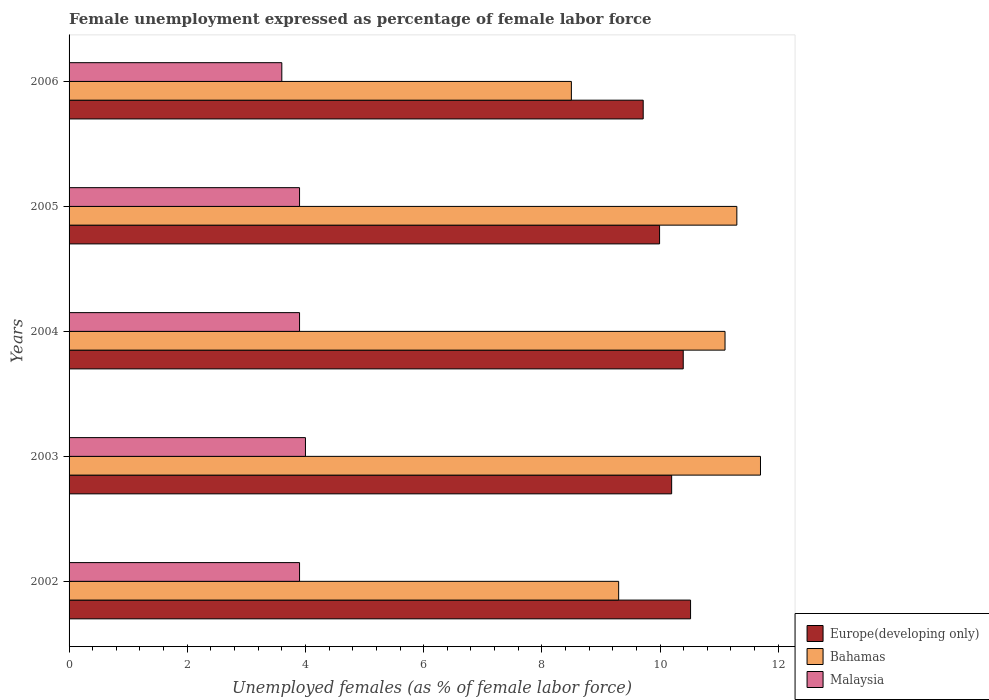How many bars are there on the 5th tick from the top?
Offer a very short reply. 3. How many bars are there on the 1st tick from the bottom?
Offer a very short reply. 3. What is the label of the 3rd group of bars from the top?
Give a very brief answer. 2004. What is the unemployment in females in in Bahamas in 2005?
Your response must be concise. 11.3. Across all years, what is the maximum unemployment in females in in Europe(developing only)?
Your answer should be compact. 10.52. Across all years, what is the minimum unemployment in females in in Malaysia?
Make the answer very short. 3.6. In which year was the unemployment in females in in Bahamas maximum?
Give a very brief answer. 2003. What is the total unemployment in females in in Europe(developing only) in the graph?
Your response must be concise. 50.81. What is the difference between the unemployment in females in in Bahamas in 2002 and that in 2006?
Make the answer very short. 0.8. What is the difference between the unemployment in females in in Europe(developing only) in 2006 and the unemployment in females in in Bahamas in 2005?
Your answer should be very brief. -1.58. What is the average unemployment in females in in Bahamas per year?
Give a very brief answer. 10.38. In the year 2004, what is the difference between the unemployment in females in in Europe(developing only) and unemployment in females in in Bahamas?
Keep it short and to the point. -0.71. What is the ratio of the unemployment in females in in Bahamas in 2004 to that in 2006?
Provide a succinct answer. 1.31. What is the difference between the highest and the second highest unemployment in females in in Malaysia?
Provide a short and direct response. 0.1. What is the difference between the highest and the lowest unemployment in females in in Malaysia?
Your response must be concise. 0.4. In how many years, is the unemployment in females in in Bahamas greater than the average unemployment in females in in Bahamas taken over all years?
Provide a succinct answer. 3. What does the 1st bar from the top in 2002 represents?
Ensure brevity in your answer.  Malaysia. What does the 2nd bar from the bottom in 2006 represents?
Make the answer very short. Bahamas. Is it the case that in every year, the sum of the unemployment in females in in Europe(developing only) and unemployment in females in in Bahamas is greater than the unemployment in females in in Malaysia?
Your response must be concise. Yes. How many bars are there?
Ensure brevity in your answer.  15. How many years are there in the graph?
Ensure brevity in your answer.  5. Does the graph contain any zero values?
Offer a very short reply. No. Does the graph contain grids?
Offer a very short reply. No. What is the title of the graph?
Your response must be concise. Female unemployment expressed as percentage of female labor force. Does "Tunisia" appear as one of the legend labels in the graph?
Provide a short and direct response. No. What is the label or title of the X-axis?
Your answer should be compact. Unemployed females (as % of female labor force). What is the Unemployed females (as % of female labor force) in Europe(developing only) in 2002?
Provide a succinct answer. 10.52. What is the Unemployed females (as % of female labor force) of Bahamas in 2002?
Your answer should be compact. 9.3. What is the Unemployed females (as % of female labor force) in Malaysia in 2002?
Your answer should be very brief. 3.9. What is the Unemployed females (as % of female labor force) of Europe(developing only) in 2003?
Make the answer very short. 10.2. What is the Unemployed females (as % of female labor force) of Bahamas in 2003?
Your answer should be compact. 11.7. What is the Unemployed females (as % of female labor force) of Malaysia in 2003?
Offer a very short reply. 4. What is the Unemployed females (as % of female labor force) in Europe(developing only) in 2004?
Ensure brevity in your answer.  10.39. What is the Unemployed females (as % of female labor force) of Bahamas in 2004?
Ensure brevity in your answer.  11.1. What is the Unemployed females (as % of female labor force) of Malaysia in 2004?
Make the answer very short. 3.9. What is the Unemployed females (as % of female labor force) in Europe(developing only) in 2005?
Give a very brief answer. 9.99. What is the Unemployed females (as % of female labor force) of Bahamas in 2005?
Ensure brevity in your answer.  11.3. What is the Unemployed females (as % of female labor force) in Malaysia in 2005?
Your response must be concise. 3.9. What is the Unemployed females (as % of female labor force) of Europe(developing only) in 2006?
Your answer should be compact. 9.72. What is the Unemployed females (as % of female labor force) of Bahamas in 2006?
Keep it short and to the point. 8.5. What is the Unemployed females (as % of female labor force) in Malaysia in 2006?
Provide a short and direct response. 3.6. Across all years, what is the maximum Unemployed females (as % of female labor force) in Europe(developing only)?
Make the answer very short. 10.52. Across all years, what is the maximum Unemployed females (as % of female labor force) of Bahamas?
Make the answer very short. 11.7. Across all years, what is the minimum Unemployed females (as % of female labor force) in Europe(developing only)?
Keep it short and to the point. 9.72. Across all years, what is the minimum Unemployed females (as % of female labor force) in Bahamas?
Offer a terse response. 8.5. Across all years, what is the minimum Unemployed females (as % of female labor force) of Malaysia?
Ensure brevity in your answer.  3.6. What is the total Unemployed females (as % of female labor force) in Europe(developing only) in the graph?
Your response must be concise. 50.81. What is the total Unemployed females (as % of female labor force) of Bahamas in the graph?
Offer a terse response. 51.9. What is the total Unemployed females (as % of female labor force) of Malaysia in the graph?
Provide a succinct answer. 19.3. What is the difference between the Unemployed females (as % of female labor force) of Europe(developing only) in 2002 and that in 2003?
Keep it short and to the point. 0.32. What is the difference between the Unemployed females (as % of female labor force) of Malaysia in 2002 and that in 2003?
Your answer should be very brief. -0.1. What is the difference between the Unemployed females (as % of female labor force) in Europe(developing only) in 2002 and that in 2004?
Your answer should be very brief. 0.12. What is the difference between the Unemployed females (as % of female labor force) of Europe(developing only) in 2002 and that in 2005?
Your response must be concise. 0.52. What is the difference between the Unemployed females (as % of female labor force) of Bahamas in 2002 and that in 2005?
Keep it short and to the point. -2. What is the difference between the Unemployed females (as % of female labor force) of Europe(developing only) in 2002 and that in 2006?
Give a very brief answer. 0.8. What is the difference between the Unemployed females (as % of female labor force) in Bahamas in 2002 and that in 2006?
Give a very brief answer. 0.8. What is the difference between the Unemployed females (as % of female labor force) in Malaysia in 2002 and that in 2006?
Your answer should be compact. 0.3. What is the difference between the Unemployed females (as % of female labor force) of Europe(developing only) in 2003 and that in 2004?
Your response must be concise. -0.2. What is the difference between the Unemployed females (as % of female labor force) of Malaysia in 2003 and that in 2004?
Make the answer very short. 0.1. What is the difference between the Unemployed females (as % of female labor force) in Europe(developing only) in 2003 and that in 2005?
Your response must be concise. 0.2. What is the difference between the Unemployed females (as % of female labor force) of Europe(developing only) in 2003 and that in 2006?
Your answer should be compact. 0.48. What is the difference between the Unemployed females (as % of female labor force) of Bahamas in 2003 and that in 2006?
Give a very brief answer. 3.2. What is the difference between the Unemployed females (as % of female labor force) of Europe(developing only) in 2004 and that in 2005?
Provide a short and direct response. 0.4. What is the difference between the Unemployed females (as % of female labor force) in Bahamas in 2004 and that in 2005?
Your response must be concise. -0.2. What is the difference between the Unemployed females (as % of female labor force) of Europe(developing only) in 2004 and that in 2006?
Offer a very short reply. 0.68. What is the difference between the Unemployed females (as % of female labor force) in Europe(developing only) in 2005 and that in 2006?
Your answer should be compact. 0.28. What is the difference between the Unemployed females (as % of female labor force) in Bahamas in 2005 and that in 2006?
Your answer should be very brief. 2.8. What is the difference between the Unemployed females (as % of female labor force) in Europe(developing only) in 2002 and the Unemployed females (as % of female labor force) in Bahamas in 2003?
Give a very brief answer. -1.18. What is the difference between the Unemployed females (as % of female labor force) of Europe(developing only) in 2002 and the Unemployed females (as % of female labor force) of Malaysia in 2003?
Provide a short and direct response. 6.52. What is the difference between the Unemployed females (as % of female labor force) in Europe(developing only) in 2002 and the Unemployed females (as % of female labor force) in Bahamas in 2004?
Provide a succinct answer. -0.58. What is the difference between the Unemployed females (as % of female labor force) of Europe(developing only) in 2002 and the Unemployed females (as % of female labor force) of Malaysia in 2004?
Ensure brevity in your answer.  6.62. What is the difference between the Unemployed females (as % of female labor force) in Europe(developing only) in 2002 and the Unemployed females (as % of female labor force) in Bahamas in 2005?
Your answer should be compact. -0.78. What is the difference between the Unemployed females (as % of female labor force) in Europe(developing only) in 2002 and the Unemployed females (as % of female labor force) in Malaysia in 2005?
Your answer should be compact. 6.62. What is the difference between the Unemployed females (as % of female labor force) of Europe(developing only) in 2002 and the Unemployed females (as % of female labor force) of Bahamas in 2006?
Make the answer very short. 2.02. What is the difference between the Unemployed females (as % of female labor force) of Europe(developing only) in 2002 and the Unemployed females (as % of female labor force) of Malaysia in 2006?
Ensure brevity in your answer.  6.92. What is the difference between the Unemployed females (as % of female labor force) of Europe(developing only) in 2003 and the Unemployed females (as % of female labor force) of Bahamas in 2004?
Make the answer very short. -0.9. What is the difference between the Unemployed females (as % of female labor force) in Europe(developing only) in 2003 and the Unemployed females (as % of female labor force) in Malaysia in 2004?
Keep it short and to the point. 6.3. What is the difference between the Unemployed females (as % of female labor force) of Bahamas in 2003 and the Unemployed females (as % of female labor force) of Malaysia in 2004?
Your response must be concise. 7.8. What is the difference between the Unemployed females (as % of female labor force) of Europe(developing only) in 2003 and the Unemployed females (as % of female labor force) of Bahamas in 2005?
Make the answer very short. -1.1. What is the difference between the Unemployed females (as % of female labor force) of Europe(developing only) in 2003 and the Unemployed females (as % of female labor force) of Malaysia in 2005?
Keep it short and to the point. 6.3. What is the difference between the Unemployed females (as % of female labor force) in Bahamas in 2003 and the Unemployed females (as % of female labor force) in Malaysia in 2005?
Your answer should be very brief. 7.8. What is the difference between the Unemployed females (as % of female labor force) in Europe(developing only) in 2003 and the Unemployed females (as % of female labor force) in Bahamas in 2006?
Provide a succinct answer. 1.7. What is the difference between the Unemployed females (as % of female labor force) in Europe(developing only) in 2003 and the Unemployed females (as % of female labor force) in Malaysia in 2006?
Provide a short and direct response. 6.6. What is the difference between the Unemployed females (as % of female labor force) of Bahamas in 2003 and the Unemployed females (as % of female labor force) of Malaysia in 2006?
Ensure brevity in your answer.  8.1. What is the difference between the Unemployed females (as % of female labor force) of Europe(developing only) in 2004 and the Unemployed females (as % of female labor force) of Bahamas in 2005?
Provide a short and direct response. -0.91. What is the difference between the Unemployed females (as % of female labor force) of Europe(developing only) in 2004 and the Unemployed females (as % of female labor force) of Malaysia in 2005?
Give a very brief answer. 6.49. What is the difference between the Unemployed females (as % of female labor force) of Europe(developing only) in 2004 and the Unemployed females (as % of female labor force) of Bahamas in 2006?
Offer a very short reply. 1.89. What is the difference between the Unemployed females (as % of female labor force) of Europe(developing only) in 2004 and the Unemployed females (as % of female labor force) of Malaysia in 2006?
Provide a succinct answer. 6.79. What is the difference between the Unemployed females (as % of female labor force) of Bahamas in 2004 and the Unemployed females (as % of female labor force) of Malaysia in 2006?
Provide a succinct answer. 7.5. What is the difference between the Unemployed females (as % of female labor force) of Europe(developing only) in 2005 and the Unemployed females (as % of female labor force) of Bahamas in 2006?
Make the answer very short. 1.49. What is the difference between the Unemployed females (as % of female labor force) in Europe(developing only) in 2005 and the Unemployed females (as % of female labor force) in Malaysia in 2006?
Offer a terse response. 6.39. What is the difference between the Unemployed females (as % of female labor force) of Bahamas in 2005 and the Unemployed females (as % of female labor force) of Malaysia in 2006?
Offer a very short reply. 7.7. What is the average Unemployed females (as % of female labor force) of Europe(developing only) per year?
Offer a terse response. 10.16. What is the average Unemployed females (as % of female labor force) of Bahamas per year?
Give a very brief answer. 10.38. What is the average Unemployed females (as % of female labor force) in Malaysia per year?
Offer a very short reply. 3.86. In the year 2002, what is the difference between the Unemployed females (as % of female labor force) of Europe(developing only) and Unemployed females (as % of female labor force) of Bahamas?
Keep it short and to the point. 1.22. In the year 2002, what is the difference between the Unemployed females (as % of female labor force) in Europe(developing only) and Unemployed females (as % of female labor force) in Malaysia?
Provide a succinct answer. 6.62. In the year 2002, what is the difference between the Unemployed females (as % of female labor force) in Bahamas and Unemployed females (as % of female labor force) in Malaysia?
Provide a short and direct response. 5.4. In the year 2003, what is the difference between the Unemployed females (as % of female labor force) in Europe(developing only) and Unemployed females (as % of female labor force) in Bahamas?
Your answer should be compact. -1.5. In the year 2003, what is the difference between the Unemployed females (as % of female labor force) of Europe(developing only) and Unemployed females (as % of female labor force) of Malaysia?
Keep it short and to the point. 6.2. In the year 2004, what is the difference between the Unemployed females (as % of female labor force) of Europe(developing only) and Unemployed females (as % of female labor force) of Bahamas?
Make the answer very short. -0.71. In the year 2004, what is the difference between the Unemployed females (as % of female labor force) in Europe(developing only) and Unemployed females (as % of female labor force) in Malaysia?
Make the answer very short. 6.49. In the year 2005, what is the difference between the Unemployed females (as % of female labor force) in Europe(developing only) and Unemployed females (as % of female labor force) in Bahamas?
Give a very brief answer. -1.31. In the year 2005, what is the difference between the Unemployed females (as % of female labor force) in Europe(developing only) and Unemployed females (as % of female labor force) in Malaysia?
Your answer should be compact. 6.09. In the year 2005, what is the difference between the Unemployed females (as % of female labor force) in Bahamas and Unemployed females (as % of female labor force) in Malaysia?
Offer a terse response. 7.4. In the year 2006, what is the difference between the Unemployed females (as % of female labor force) in Europe(developing only) and Unemployed females (as % of female labor force) in Bahamas?
Provide a succinct answer. 1.22. In the year 2006, what is the difference between the Unemployed females (as % of female labor force) of Europe(developing only) and Unemployed females (as % of female labor force) of Malaysia?
Provide a succinct answer. 6.12. What is the ratio of the Unemployed females (as % of female labor force) of Europe(developing only) in 2002 to that in 2003?
Provide a succinct answer. 1.03. What is the ratio of the Unemployed females (as % of female labor force) in Bahamas in 2002 to that in 2003?
Give a very brief answer. 0.79. What is the ratio of the Unemployed females (as % of female labor force) of Europe(developing only) in 2002 to that in 2004?
Offer a terse response. 1.01. What is the ratio of the Unemployed females (as % of female labor force) of Bahamas in 2002 to that in 2004?
Ensure brevity in your answer.  0.84. What is the ratio of the Unemployed females (as % of female labor force) of Europe(developing only) in 2002 to that in 2005?
Offer a terse response. 1.05. What is the ratio of the Unemployed females (as % of female labor force) in Bahamas in 2002 to that in 2005?
Offer a terse response. 0.82. What is the ratio of the Unemployed females (as % of female labor force) in Europe(developing only) in 2002 to that in 2006?
Offer a very short reply. 1.08. What is the ratio of the Unemployed females (as % of female labor force) of Bahamas in 2002 to that in 2006?
Provide a succinct answer. 1.09. What is the ratio of the Unemployed females (as % of female labor force) in Malaysia in 2002 to that in 2006?
Provide a short and direct response. 1.08. What is the ratio of the Unemployed females (as % of female labor force) of Europe(developing only) in 2003 to that in 2004?
Make the answer very short. 0.98. What is the ratio of the Unemployed females (as % of female labor force) in Bahamas in 2003 to that in 2004?
Provide a succinct answer. 1.05. What is the ratio of the Unemployed females (as % of female labor force) in Malaysia in 2003 to that in 2004?
Your answer should be very brief. 1.03. What is the ratio of the Unemployed females (as % of female labor force) in Europe(developing only) in 2003 to that in 2005?
Your answer should be compact. 1.02. What is the ratio of the Unemployed females (as % of female labor force) in Bahamas in 2003 to that in 2005?
Provide a short and direct response. 1.04. What is the ratio of the Unemployed females (as % of female labor force) in Malaysia in 2003 to that in 2005?
Ensure brevity in your answer.  1.03. What is the ratio of the Unemployed females (as % of female labor force) of Europe(developing only) in 2003 to that in 2006?
Give a very brief answer. 1.05. What is the ratio of the Unemployed females (as % of female labor force) in Bahamas in 2003 to that in 2006?
Your answer should be very brief. 1.38. What is the ratio of the Unemployed females (as % of female labor force) in Europe(developing only) in 2004 to that in 2005?
Make the answer very short. 1.04. What is the ratio of the Unemployed females (as % of female labor force) in Bahamas in 2004 to that in 2005?
Ensure brevity in your answer.  0.98. What is the ratio of the Unemployed females (as % of female labor force) of Malaysia in 2004 to that in 2005?
Provide a short and direct response. 1. What is the ratio of the Unemployed females (as % of female labor force) of Europe(developing only) in 2004 to that in 2006?
Provide a short and direct response. 1.07. What is the ratio of the Unemployed females (as % of female labor force) in Bahamas in 2004 to that in 2006?
Keep it short and to the point. 1.31. What is the ratio of the Unemployed females (as % of female labor force) in Europe(developing only) in 2005 to that in 2006?
Give a very brief answer. 1.03. What is the ratio of the Unemployed females (as % of female labor force) in Bahamas in 2005 to that in 2006?
Give a very brief answer. 1.33. What is the difference between the highest and the second highest Unemployed females (as % of female labor force) in Europe(developing only)?
Give a very brief answer. 0.12. What is the difference between the highest and the second highest Unemployed females (as % of female labor force) in Malaysia?
Provide a succinct answer. 0.1. What is the difference between the highest and the lowest Unemployed females (as % of female labor force) in Europe(developing only)?
Make the answer very short. 0.8. 